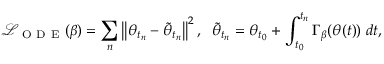<formula> <loc_0><loc_0><loc_500><loc_500>\mathcal { L } _ { O D E } ( \beta ) = \sum _ { n } \left \| \theta _ { t _ { n } } - \tilde { \theta } _ { t _ { n } } \right \| ^ { 2 } , \, \tilde { \theta } _ { t _ { n } } = \theta _ { t _ { 0 } } + \int _ { t _ { 0 } } ^ { t _ { n } } \Gamma _ { \beta } ( \theta ( t ) ) \, d t ,</formula> 